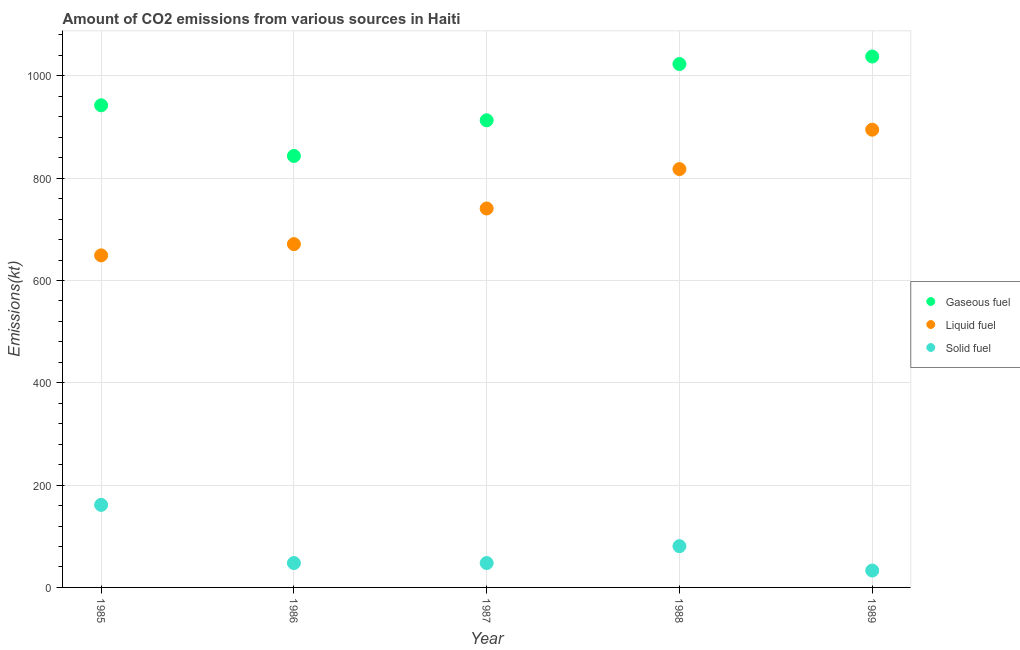How many different coloured dotlines are there?
Provide a short and direct response. 3. Is the number of dotlines equal to the number of legend labels?
Your response must be concise. Yes. What is the amount of co2 emissions from solid fuel in 1988?
Your answer should be very brief. 80.67. Across all years, what is the maximum amount of co2 emissions from gaseous fuel?
Your answer should be compact. 1037.76. Across all years, what is the minimum amount of co2 emissions from solid fuel?
Your response must be concise. 33. In which year was the amount of co2 emissions from gaseous fuel maximum?
Make the answer very short. 1989. What is the total amount of co2 emissions from gaseous fuel in the graph?
Your response must be concise. 4759.77. What is the difference between the amount of co2 emissions from solid fuel in 1988 and that in 1989?
Your answer should be very brief. 47.67. What is the difference between the amount of co2 emissions from gaseous fuel in 1988 and the amount of co2 emissions from solid fuel in 1986?
Your answer should be compact. 975.42. What is the average amount of co2 emissions from gaseous fuel per year?
Keep it short and to the point. 951.95. In the year 1988, what is the difference between the amount of co2 emissions from liquid fuel and amount of co2 emissions from solid fuel?
Keep it short and to the point. 737.07. In how many years, is the amount of co2 emissions from solid fuel greater than 440 kt?
Offer a very short reply. 0. What is the ratio of the amount of co2 emissions from liquid fuel in 1985 to that in 1986?
Offer a very short reply. 0.97. Is the amount of co2 emissions from solid fuel in 1985 less than that in 1986?
Provide a short and direct response. No. What is the difference between the highest and the second highest amount of co2 emissions from solid fuel?
Give a very brief answer. 80.67. What is the difference between the highest and the lowest amount of co2 emissions from solid fuel?
Offer a terse response. 128.35. In how many years, is the amount of co2 emissions from liquid fuel greater than the average amount of co2 emissions from liquid fuel taken over all years?
Ensure brevity in your answer.  2. Is the sum of the amount of co2 emissions from gaseous fuel in 1988 and 1989 greater than the maximum amount of co2 emissions from solid fuel across all years?
Make the answer very short. Yes. Is it the case that in every year, the sum of the amount of co2 emissions from gaseous fuel and amount of co2 emissions from liquid fuel is greater than the amount of co2 emissions from solid fuel?
Your answer should be compact. Yes. Is the amount of co2 emissions from liquid fuel strictly greater than the amount of co2 emissions from solid fuel over the years?
Provide a short and direct response. Yes. How many years are there in the graph?
Keep it short and to the point. 5. What is the difference between two consecutive major ticks on the Y-axis?
Provide a short and direct response. 200. Are the values on the major ticks of Y-axis written in scientific E-notation?
Keep it short and to the point. No. Does the graph contain any zero values?
Offer a terse response. No. Does the graph contain grids?
Ensure brevity in your answer.  Yes. How many legend labels are there?
Provide a succinct answer. 3. What is the title of the graph?
Give a very brief answer. Amount of CO2 emissions from various sources in Haiti. What is the label or title of the Y-axis?
Provide a succinct answer. Emissions(kt). What is the Emissions(kt) of Gaseous fuel in 1985?
Your response must be concise. 942.42. What is the Emissions(kt) of Liquid fuel in 1985?
Keep it short and to the point. 649.06. What is the Emissions(kt) of Solid fuel in 1985?
Provide a succinct answer. 161.35. What is the Emissions(kt) in Gaseous fuel in 1986?
Your answer should be very brief. 843.41. What is the Emissions(kt) of Liquid fuel in 1986?
Ensure brevity in your answer.  671.06. What is the Emissions(kt) of Solid fuel in 1986?
Ensure brevity in your answer.  47.67. What is the Emissions(kt) in Gaseous fuel in 1987?
Provide a succinct answer. 913.08. What is the Emissions(kt) in Liquid fuel in 1987?
Your answer should be compact. 740.73. What is the Emissions(kt) of Solid fuel in 1987?
Your answer should be very brief. 47.67. What is the Emissions(kt) of Gaseous fuel in 1988?
Your response must be concise. 1023.09. What is the Emissions(kt) in Liquid fuel in 1988?
Provide a short and direct response. 817.74. What is the Emissions(kt) of Solid fuel in 1988?
Offer a very short reply. 80.67. What is the Emissions(kt) of Gaseous fuel in 1989?
Your response must be concise. 1037.76. What is the Emissions(kt) of Liquid fuel in 1989?
Offer a very short reply. 894.75. What is the Emissions(kt) in Solid fuel in 1989?
Keep it short and to the point. 33. Across all years, what is the maximum Emissions(kt) in Gaseous fuel?
Your response must be concise. 1037.76. Across all years, what is the maximum Emissions(kt) of Liquid fuel?
Offer a terse response. 894.75. Across all years, what is the maximum Emissions(kt) of Solid fuel?
Make the answer very short. 161.35. Across all years, what is the minimum Emissions(kt) of Gaseous fuel?
Offer a terse response. 843.41. Across all years, what is the minimum Emissions(kt) of Liquid fuel?
Give a very brief answer. 649.06. Across all years, what is the minimum Emissions(kt) of Solid fuel?
Offer a terse response. 33. What is the total Emissions(kt) of Gaseous fuel in the graph?
Your answer should be compact. 4759.77. What is the total Emissions(kt) of Liquid fuel in the graph?
Ensure brevity in your answer.  3773.34. What is the total Emissions(kt) of Solid fuel in the graph?
Your answer should be very brief. 370.37. What is the difference between the Emissions(kt) in Gaseous fuel in 1985 and that in 1986?
Provide a succinct answer. 99.01. What is the difference between the Emissions(kt) in Liquid fuel in 1985 and that in 1986?
Keep it short and to the point. -22. What is the difference between the Emissions(kt) in Solid fuel in 1985 and that in 1986?
Keep it short and to the point. 113.68. What is the difference between the Emissions(kt) in Gaseous fuel in 1985 and that in 1987?
Provide a succinct answer. 29.34. What is the difference between the Emissions(kt) of Liquid fuel in 1985 and that in 1987?
Offer a very short reply. -91.67. What is the difference between the Emissions(kt) in Solid fuel in 1985 and that in 1987?
Your answer should be very brief. 113.68. What is the difference between the Emissions(kt) of Gaseous fuel in 1985 and that in 1988?
Your answer should be very brief. -80.67. What is the difference between the Emissions(kt) in Liquid fuel in 1985 and that in 1988?
Offer a very short reply. -168.68. What is the difference between the Emissions(kt) in Solid fuel in 1985 and that in 1988?
Your answer should be very brief. 80.67. What is the difference between the Emissions(kt) of Gaseous fuel in 1985 and that in 1989?
Your answer should be very brief. -95.34. What is the difference between the Emissions(kt) in Liquid fuel in 1985 and that in 1989?
Provide a succinct answer. -245.69. What is the difference between the Emissions(kt) of Solid fuel in 1985 and that in 1989?
Your answer should be very brief. 128.34. What is the difference between the Emissions(kt) in Gaseous fuel in 1986 and that in 1987?
Keep it short and to the point. -69.67. What is the difference between the Emissions(kt) in Liquid fuel in 1986 and that in 1987?
Make the answer very short. -69.67. What is the difference between the Emissions(kt) in Gaseous fuel in 1986 and that in 1988?
Provide a short and direct response. -179.68. What is the difference between the Emissions(kt) of Liquid fuel in 1986 and that in 1988?
Give a very brief answer. -146.68. What is the difference between the Emissions(kt) in Solid fuel in 1986 and that in 1988?
Give a very brief answer. -33. What is the difference between the Emissions(kt) in Gaseous fuel in 1986 and that in 1989?
Make the answer very short. -194.35. What is the difference between the Emissions(kt) in Liquid fuel in 1986 and that in 1989?
Make the answer very short. -223.69. What is the difference between the Emissions(kt) of Solid fuel in 1986 and that in 1989?
Your response must be concise. 14.67. What is the difference between the Emissions(kt) in Gaseous fuel in 1987 and that in 1988?
Make the answer very short. -110.01. What is the difference between the Emissions(kt) of Liquid fuel in 1987 and that in 1988?
Offer a very short reply. -77.01. What is the difference between the Emissions(kt) of Solid fuel in 1987 and that in 1988?
Your answer should be compact. -33. What is the difference between the Emissions(kt) in Gaseous fuel in 1987 and that in 1989?
Give a very brief answer. -124.68. What is the difference between the Emissions(kt) in Liquid fuel in 1987 and that in 1989?
Your answer should be compact. -154.01. What is the difference between the Emissions(kt) in Solid fuel in 1987 and that in 1989?
Provide a succinct answer. 14.67. What is the difference between the Emissions(kt) in Gaseous fuel in 1988 and that in 1989?
Your answer should be very brief. -14.67. What is the difference between the Emissions(kt) in Liquid fuel in 1988 and that in 1989?
Offer a terse response. -77.01. What is the difference between the Emissions(kt) of Solid fuel in 1988 and that in 1989?
Your answer should be very brief. 47.67. What is the difference between the Emissions(kt) in Gaseous fuel in 1985 and the Emissions(kt) in Liquid fuel in 1986?
Provide a succinct answer. 271.36. What is the difference between the Emissions(kt) of Gaseous fuel in 1985 and the Emissions(kt) of Solid fuel in 1986?
Keep it short and to the point. 894.75. What is the difference between the Emissions(kt) of Liquid fuel in 1985 and the Emissions(kt) of Solid fuel in 1986?
Make the answer very short. 601.39. What is the difference between the Emissions(kt) in Gaseous fuel in 1985 and the Emissions(kt) in Liquid fuel in 1987?
Offer a very short reply. 201.69. What is the difference between the Emissions(kt) of Gaseous fuel in 1985 and the Emissions(kt) of Solid fuel in 1987?
Ensure brevity in your answer.  894.75. What is the difference between the Emissions(kt) in Liquid fuel in 1985 and the Emissions(kt) in Solid fuel in 1987?
Provide a short and direct response. 601.39. What is the difference between the Emissions(kt) in Gaseous fuel in 1985 and the Emissions(kt) in Liquid fuel in 1988?
Provide a short and direct response. 124.68. What is the difference between the Emissions(kt) of Gaseous fuel in 1985 and the Emissions(kt) of Solid fuel in 1988?
Your response must be concise. 861.75. What is the difference between the Emissions(kt) of Liquid fuel in 1985 and the Emissions(kt) of Solid fuel in 1988?
Give a very brief answer. 568.38. What is the difference between the Emissions(kt) of Gaseous fuel in 1985 and the Emissions(kt) of Liquid fuel in 1989?
Provide a short and direct response. 47.67. What is the difference between the Emissions(kt) in Gaseous fuel in 1985 and the Emissions(kt) in Solid fuel in 1989?
Ensure brevity in your answer.  909.42. What is the difference between the Emissions(kt) of Liquid fuel in 1985 and the Emissions(kt) of Solid fuel in 1989?
Offer a terse response. 616.06. What is the difference between the Emissions(kt) of Gaseous fuel in 1986 and the Emissions(kt) of Liquid fuel in 1987?
Your response must be concise. 102.68. What is the difference between the Emissions(kt) of Gaseous fuel in 1986 and the Emissions(kt) of Solid fuel in 1987?
Make the answer very short. 795.74. What is the difference between the Emissions(kt) of Liquid fuel in 1986 and the Emissions(kt) of Solid fuel in 1987?
Provide a succinct answer. 623.39. What is the difference between the Emissions(kt) of Gaseous fuel in 1986 and the Emissions(kt) of Liquid fuel in 1988?
Provide a short and direct response. 25.67. What is the difference between the Emissions(kt) of Gaseous fuel in 1986 and the Emissions(kt) of Solid fuel in 1988?
Your answer should be compact. 762.74. What is the difference between the Emissions(kt) of Liquid fuel in 1986 and the Emissions(kt) of Solid fuel in 1988?
Ensure brevity in your answer.  590.39. What is the difference between the Emissions(kt) in Gaseous fuel in 1986 and the Emissions(kt) in Liquid fuel in 1989?
Offer a terse response. -51.34. What is the difference between the Emissions(kt) in Gaseous fuel in 1986 and the Emissions(kt) in Solid fuel in 1989?
Your answer should be very brief. 810.41. What is the difference between the Emissions(kt) in Liquid fuel in 1986 and the Emissions(kt) in Solid fuel in 1989?
Make the answer very short. 638.06. What is the difference between the Emissions(kt) in Gaseous fuel in 1987 and the Emissions(kt) in Liquid fuel in 1988?
Keep it short and to the point. 95.34. What is the difference between the Emissions(kt) in Gaseous fuel in 1987 and the Emissions(kt) in Solid fuel in 1988?
Offer a very short reply. 832.41. What is the difference between the Emissions(kt) of Liquid fuel in 1987 and the Emissions(kt) of Solid fuel in 1988?
Ensure brevity in your answer.  660.06. What is the difference between the Emissions(kt) in Gaseous fuel in 1987 and the Emissions(kt) in Liquid fuel in 1989?
Your answer should be compact. 18.34. What is the difference between the Emissions(kt) in Gaseous fuel in 1987 and the Emissions(kt) in Solid fuel in 1989?
Provide a succinct answer. 880.08. What is the difference between the Emissions(kt) of Liquid fuel in 1987 and the Emissions(kt) of Solid fuel in 1989?
Provide a succinct answer. 707.73. What is the difference between the Emissions(kt) of Gaseous fuel in 1988 and the Emissions(kt) of Liquid fuel in 1989?
Provide a succinct answer. 128.34. What is the difference between the Emissions(kt) in Gaseous fuel in 1988 and the Emissions(kt) in Solid fuel in 1989?
Keep it short and to the point. 990.09. What is the difference between the Emissions(kt) of Liquid fuel in 1988 and the Emissions(kt) of Solid fuel in 1989?
Ensure brevity in your answer.  784.74. What is the average Emissions(kt) of Gaseous fuel per year?
Your answer should be compact. 951.95. What is the average Emissions(kt) of Liquid fuel per year?
Your response must be concise. 754.67. What is the average Emissions(kt) in Solid fuel per year?
Provide a succinct answer. 74.07. In the year 1985, what is the difference between the Emissions(kt) of Gaseous fuel and Emissions(kt) of Liquid fuel?
Offer a terse response. 293.36. In the year 1985, what is the difference between the Emissions(kt) in Gaseous fuel and Emissions(kt) in Solid fuel?
Provide a succinct answer. 781.07. In the year 1985, what is the difference between the Emissions(kt) in Liquid fuel and Emissions(kt) in Solid fuel?
Your answer should be compact. 487.71. In the year 1986, what is the difference between the Emissions(kt) in Gaseous fuel and Emissions(kt) in Liquid fuel?
Your response must be concise. 172.35. In the year 1986, what is the difference between the Emissions(kt) of Gaseous fuel and Emissions(kt) of Solid fuel?
Make the answer very short. 795.74. In the year 1986, what is the difference between the Emissions(kt) in Liquid fuel and Emissions(kt) in Solid fuel?
Ensure brevity in your answer.  623.39. In the year 1987, what is the difference between the Emissions(kt) in Gaseous fuel and Emissions(kt) in Liquid fuel?
Make the answer very short. 172.35. In the year 1987, what is the difference between the Emissions(kt) of Gaseous fuel and Emissions(kt) of Solid fuel?
Provide a succinct answer. 865.41. In the year 1987, what is the difference between the Emissions(kt) of Liquid fuel and Emissions(kt) of Solid fuel?
Give a very brief answer. 693.06. In the year 1988, what is the difference between the Emissions(kt) of Gaseous fuel and Emissions(kt) of Liquid fuel?
Offer a terse response. 205.35. In the year 1988, what is the difference between the Emissions(kt) in Gaseous fuel and Emissions(kt) in Solid fuel?
Offer a terse response. 942.42. In the year 1988, what is the difference between the Emissions(kt) in Liquid fuel and Emissions(kt) in Solid fuel?
Offer a terse response. 737.07. In the year 1989, what is the difference between the Emissions(kt) of Gaseous fuel and Emissions(kt) of Liquid fuel?
Your response must be concise. 143.01. In the year 1989, what is the difference between the Emissions(kt) of Gaseous fuel and Emissions(kt) of Solid fuel?
Offer a terse response. 1004.76. In the year 1989, what is the difference between the Emissions(kt) in Liquid fuel and Emissions(kt) in Solid fuel?
Your answer should be compact. 861.75. What is the ratio of the Emissions(kt) of Gaseous fuel in 1985 to that in 1986?
Your answer should be very brief. 1.12. What is the ratio of the Emissions(kt) in Liquid fuel in 1985 to that in 1986?
Your answer should be compact. 0.97. What is the ratio of the Emissions(kt) of Solid fuel in 1985 to that in 1986?
Offer a terse response. 3.38. What is the ratio of the Emissions(kt) of Gaseous fuel in 1985 to that in 1987?
Ensure brevity in your answer.  1.03. What is the ratio of the Emissions(kt) of Liquid fuel in 1985 to that in 1987?
Give a very brief answer. 0.88. What is the ratio of the Emissions(kt) in Solid fuel in 1985 to that in 1987?
Offer a terse response. 3.38. What is the ratio of the Emissions(kt) in Gaseous fuel in 1985 to that in 1988?
Offer a very short reply. 0.92. What is the ratio of the Emissions(kt) in Liquid fuel in 1985 to that in 1988?
Your answer should be compact. 0.79. What is the ratio of the Emissions(kt) of Solid fuel in 1985 to that in 1988?
Provide a succinct answer. 2. What is the ratio of the Emissions(kt) in Gaseous fuel in 1985 to that in 1989?
Offer a very short reply. 0.91. What is the ratio of the Emissions(kt) in Liquid fuel in 1985 to that in 1989?
Your answer should be compact. 0.73. What is the ratio of the Emissions(kt) of Solid fuel in 1985 to that in 1989?
Offer a terse response. 4.89. What is the ratio of the Emissions(kt) of Gaseous fuel in 1986 to that in 1987?
Your answer should be compact. 0.92. What is the ratio of the Emissions(kt) in Liquid fuel in 1986 to that in 1987?
Provide a short and direct response. 0.91. What is the ratio of the Emissions(kt) in Solid fuel in 1986 to that in 1987?
Your response must be concise. 1. What is the ratio of the Emissions(kt) of Gaseous fuel in 1986 to that in 1988?
Provide a succinct answer. 0.82. What is the ratio of the Emissions(kt) in Liquid fuel in 1986 to that in 1988?
Offer a terse response. 0.82. What is the ratio of the Emissions(kt) in Solid fuel in 1986 to that in 1988?
Your answer should be compact. 0.59. What is the ratio of the Emissions(kt) of Gaseous fuel in 1986 to that in 1989?
Offer a very short reply. 0.81. What is the ratio of the Emissions(kt) of Liquid fuel in 1986 to that in 1989?
Make the answer very short. 0.75. What is the ratio of the Emissions(kt) in Solid fuel in 1986 to that in 1989?
Offer a very short reply. 1.44. What is the ratio of the Emissions(kt) of Gaseous fuel in 1987 to that in 1988?
Offer a terse response. 0.89. What is the ratio of the Emissions(kt) of Liquid fuel in 1987 to that in 1988?
Offer a very short reply. 0.91. What is the ratio of the Emissions(kt) in Solid fuel in 1987 to that in 1988?
Make the answer very short. 0.59. What is the ratio of the Emissions(kt) in Gaseous fuel in 1987 to that in 1989?
Provide a succinct answer. 0.88. What is the ratio of the Emissions(kt) in Liquid fuel in 1987 to that in 1989?
Make the answer very short. 0.83. What is the ratio of the Emissions(kt) of Solid fuel in 1987 to that in 1989?
Offer a terse response. 1.44. What is the ratio of the Emissions(kt) of Gaseous fuel in 1988 to that in 1989?
Offer a very short reply. 0.99. What is the ratio of the Emissions(kt) in Liquid fuel in 1988 to that in 1989?
Your response must be concise. 0.91. What is the ratio of the Emissions(kt) of Solid fuel in 1988 to that in 1989?
Provide a short and direct response. 2.44. What is the difference between the highest and the second highest Emissions(kt) of Gaseous fuel?
Ensure brevity in your answer.  14.67. What is the difference between the highest and the second highest Emissions(kt) in Liquid fuel?
Your answer should be compact. 77.01. What is the difference between the highest and the second highest Emissions(kt) in Solid fuel?
Give a very brief answer. 80.67. What is the difference between the highest and the lowest Emissions(kt) in Gaseous fuel?
Your answer should be very brief. 194.35. What is the difference between the highest and the lowest Emissions(kt) of Liquid fuel?
Make the answer very short. 245.69. What is the difference between the highest and the lowest Emissions(kt) of Solid fuel?
Offer a very short reply. 128.34. 